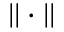Convert formula to latex. <formula><loc_0><loc_0><loc_500><loc_500>| | \cdot | |</formula> 